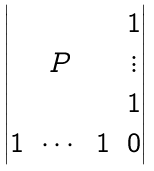Convert formula to latex. <formula><loc_0><loc_0><loc_500><loc_500>\begin{vmatrix} & & & 1 \\ & P & & \vdots \\ & & & 1 \\ 1 & \cdots & 1 & 0 \end{vmatrix}</formula> 